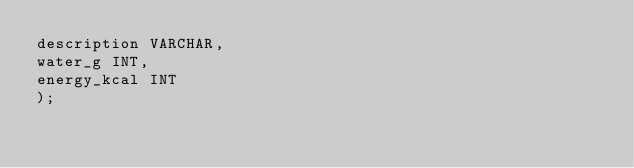Convert code to text. <code><loc_0><loc_0><loc_500><loc_500><_SQL_>description VARCHAR,
water_g INT,
energy_kcal INT
);</code> 